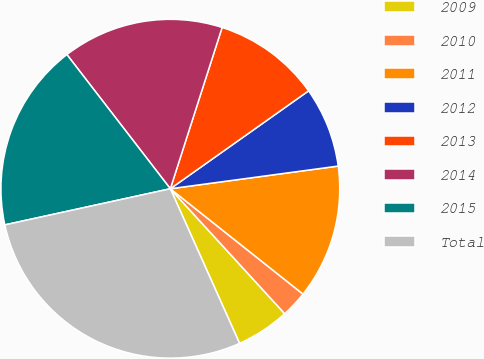Convert chart to OTSL. <chart><loc_0><loc_0><loc_500><loc_500><pie_chart><fcel>2009<fcel>2010<fcel>2011<fcel>2012<fcel>2013<fcel>2014<fcel>2015<fcel>Total<nl><fcel>5.1%<fcel>2.52%<fcel>12.82%<fcel>7.67%<fcel>10.25%<fcel>15.4%<fcel>17.97%<fcel>28.28%<nl></chart> 